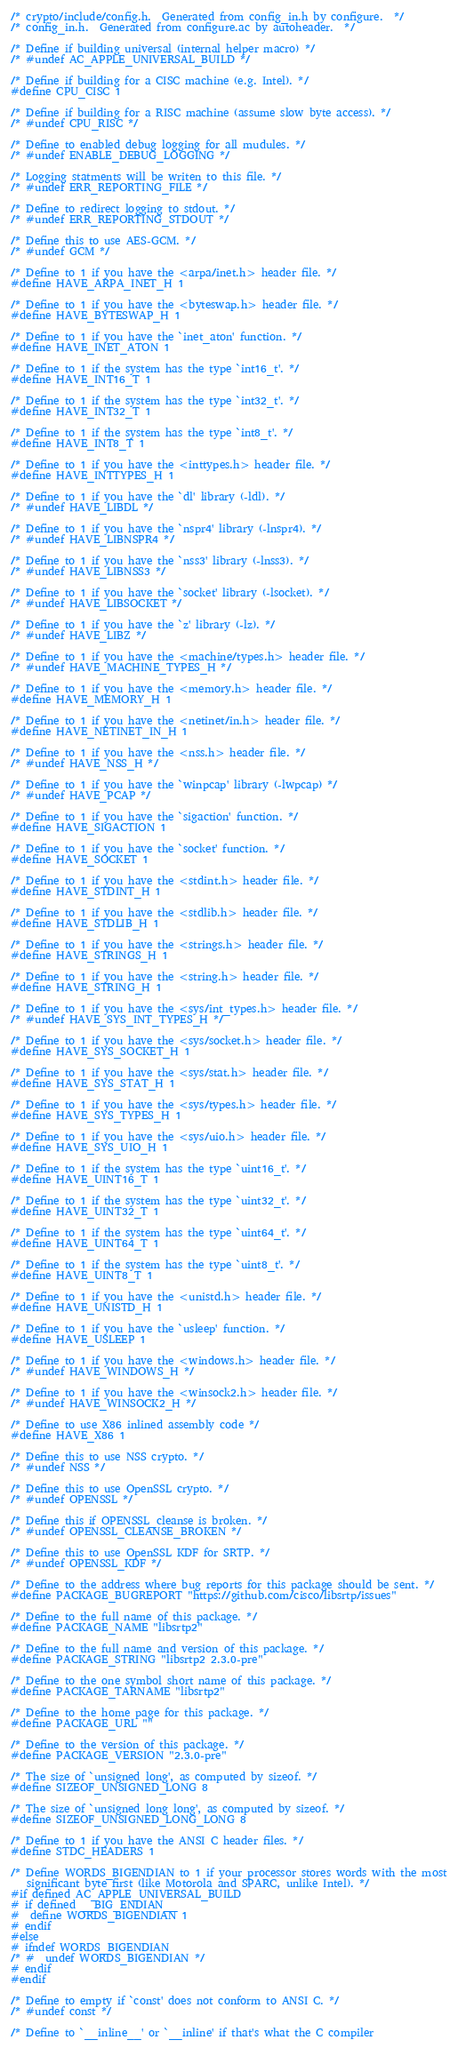Convert code to text. <code><loc_0><loc_0><loc_500><loc_500><_C_>/* crypto/include/config.h.  Generated from config_in.h by configure.  */
/* config_in.h.  Generated from configure.ac by autoheader.  */

/* Define if building universal (internal helper macro) */
/* #undef AC_APPLE_UNIVERSAL_BUILD */

/* Define if building for a CISC machine (e.g. Intel). */
#define CPU_CISC 1

/* Define if building for a RISC machine (assume slow byte access). */
/* #undef CPU_RISC */

/* Define to enabled debug logging for all mudules. */
/* #undef ENABLE_DEBUG_LOGGING */

/* Logging statments will be writen to this file. */
/* #undef ERR_REPORTING_FILE */

/* Define to redirect logging to stdout. */
/* #undef ERR_REPORTING_STDOUT */

/* Define this to use AES-GCM. */
/* #undef GCM */

/* Define to 1 if you have the <arpa/inet.h> header file. */
#define HAVE_ARPA_INET_H 1

/* Define to 1 if you have the <byteswap.h> header file. */
#define HAVE_BYTESWAP_H 1

/* Define to 1 if you have the `inet_aton' function. */
#define HAVE_INET_ATON 1

/* Define to 1 if the system has the type `int16_t'. */
#define HAVE_INT16_T 1

/* Define to 1 if the system has the type `int32_t'. */
#define HAVE_INT32_T 1

/* Define to 1 if the system has the type `int8_t'. */
#define HAVE_INT8_T 1

/* Define to 1 if you have the <inttypes.h> header file. */
#define HAVE_INTTYPES_H 1

/* Define to 1 if you have the `dl' library (-ldl). */
/* #undef HAVE_LIBDL */

/* Define to 1 if you have the `nspr4' library (-lnspr4). */
/* #undef HAVE_LIBNSPR4 */

/* Define to 1 if you have the `nss3' library (-lnss3). */
/* #undef HAVE_LIBNSS3 */

/* Define to 1 if you have the `socket' library (-lsocket). */
/* #undef HAVE_LIBSOCKET */

/* Define to 1 if you have the `z' library (-lz). */
/* #undef HAVE_LIBZ */

/* Define to 1 if you have the <machine/types.h> header file. */
/* #undef HAVE_MACHINE_TYPES_H */

/* Define to 1 if you have the <memory.h> header file. */
#define HAVE_MEMORY_H 1

/* Define to 1 if you have the <netinet/in.h> header file. */
#define HAVE_NETINET_IN_H 1

/* Define to 1 if you have the <nss.h> header file. */
/* #undef HAVE_NSS_H */

/* Define to 1 if you have the `winpcap' library (-lwpcap) */
/* #undef HAVE_PCAP */

/* Define to 1 if you have the `sigaction' function. */
#define HAVE_SIGACTION 1

/* Define to 1 if you have the `socket' function. */
#define HAVE_SOCKET 1

/* Define to 1 if you have the <stdint.h> header file. */
#define HAVE_STDINT_H 1

/* Define to 1 if you have the <stdlib.h> header file. */
#define HAVE_STDLIB_H 1

/* Define to 1 if you have the <strings.h> header file. */
#define HAVE_STRINGS_H 1

/* Define to 1 if you have the <string.h> header file. */
#define HAVE_STRING_H 1

/* Define to 1 if you have the <sys/int_types.h> header file. */
/* #undef HAVE_SYS_INT_TYPES_H */

/* Define to 1 if you have the <sys/socket.h> header file. */
#define HAVE_SYS_SOCKET_H 1

/* Define to 1 if you have the <sys/stat.h> header file. */
#define HAVE_SYS_STAT_H 1

/* Define to 1 if you have the <sys/types.h> header file. */
#define HAVE_SYS_TYPES_H 1

/* Define to 1 if you have the <sys/uio.h> header file. */
#define HAVE_SYS_UIO_H 1

/* Define to 1 if the system has the type `uint16_t'. */
#define HAVE_UINT16_T 1

/* Define to 1 if the system has the type `uint32_t'. */
#define HAVE_UINT32_T 1

/* Define to 1 if the system has the type `uint64_t'. */
#define HAVE_UINT64_T 1

/* Define to 1 if the system has the type `uint8_t'. */
#define HAVE_UINT8_T 1

/* Define to 1 if you have the <unistd.h> header file. */
#define HAVE_UNISTD_H 1

/* Define to 1 if you have the `usleep' function. */
#define HAVE_USLEEP 1

/* Define to 1 if you have the <windows.h> header file. */
/* #undef HAVE_WINDOWS_H */

/* Define to 1 if you have the <winsock2.h> header file. */
/* #undef HAVE_WINSOCK2_H */

/* Define to use X86 inlined assembly code */
#define HAVE_X86 1

/* Define this to use NSS crypto. */
/* #undef NSS */

/* Define this to use OpenSSL crypto. */
/* #undef OPENSSL */

/* Define this if OPENSSL_cleanse is broken. */
/* #undef OPENSSL_CLEANSE_BROKEN */

/* Define this to use OpenSSL KDF for SRTP. */
/* #undef OPENSSL_KDF */

/* Define to the address where bug reports for this package should be sent. */
#define PACKAGE_BUGREPORT "https://github.com/cisco/libsrtp/issues"

/* Define to the full name of this package. */
#define PACKAGE_NAME "libsrtp2"

/* Define to the full name and version of this package. */
#define PACKAGE_STRING "libsrtp2 2.3.0-pre"

/* Define to the one symbol short name of this package. */
#define PACKAGE_TARNAME "libsrtp2"

/* Define to the home page for this package. */
#define PACKAGE_URL ""

/* Define to the version of this package. */
#define PACKAGE_VERSION "2.3.0-pre"

/* The size of `unsigned long', as computed by sizeof. */
#define SIZEOF_UNSIGNED_LONG 8

/* The size of `unsigned long long', as computed by sizeof. */
#define SIZEOF_UNSIGNED_LONG_LONG 8

/* Define to 1 if you have the ANSI C header files. */
#define STDC_HEADERS 1

/* Define WORDS_BIGENDIAN to 1 if your processor stores words with the most
   significant byte first (like Motorola and SPARC, unlike Intel). */
#if defined AC_APPLE_UNIVERSAL_BUILD
# if defined __BIG_ENDIAN__
#  define WORDS_BIGENDIAN 1
# endif
#else
# ifndef WORDS_BIGENDIAN
/* #  undef WORDS_BIGENDIAN */
# endif
#endif

/* Define to empty if `const' does not conform to ANSI C. */
/* #undef const */

/* Define to `__inline__' or `__inline' if that's what the C compiler</code> 